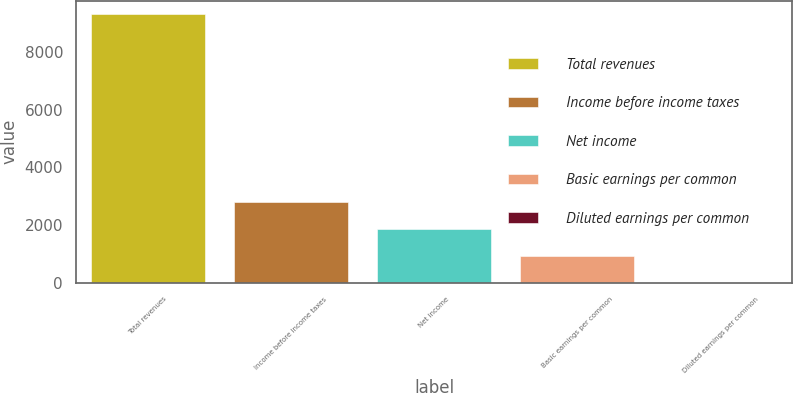Convert chart to OTSL. <chart><loc_0><loc_0><loc_500><loc_500><bar_chart><fcel>Total revenues<fcel>Income before income taxes<fcel>Net income<fcel>Basic earnings per common<fcel>Diluted earnings per common<nl><fcel>9301<fcel>2792.16<fcel>1862.33<fcel>932.5<fcel>2.67<nl></chart> 